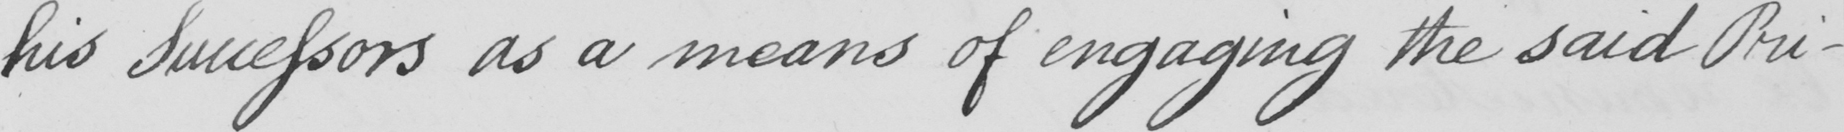Can you read and transcribe this handwriting? his Successors as a means of engaging the said Pri- 